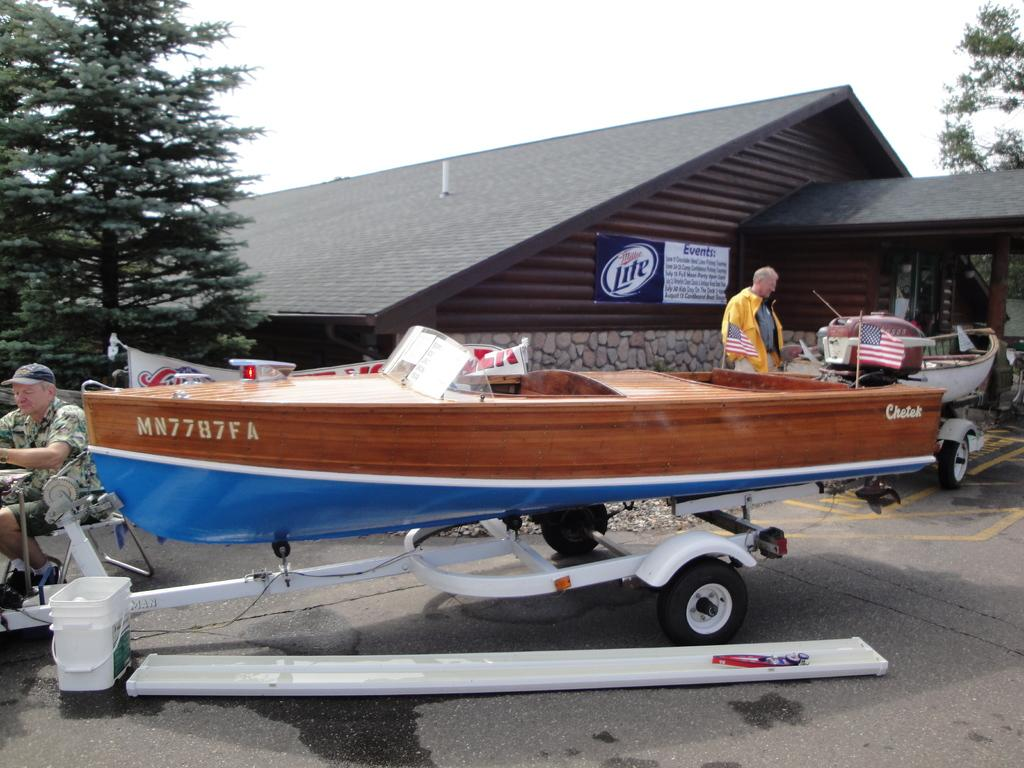<image>
Render a clear and concise summary of the photo. A brown and blue boat is parked in front of a Miller Lite sign on a building 